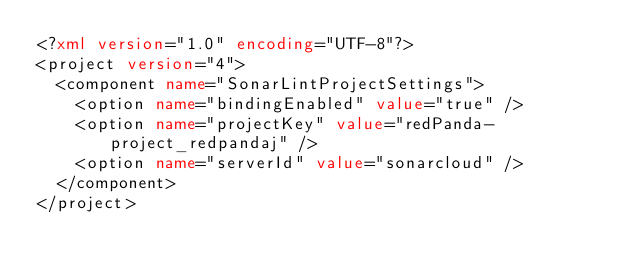<code> <loc_0><loc_0><loc_500><loc_500><_XML_><?xml version="1.0" encoding="UTF-8"?>
<project version="4">
  <component name="SonarLintProjectSettings">
    <option name="bindingEnabled" value="true" />
    <option name="projectKey" value="redPanda-project_redpandaj" />
    <option name="serverId" value="sonarcloud" />
  </component>
</project></code> 